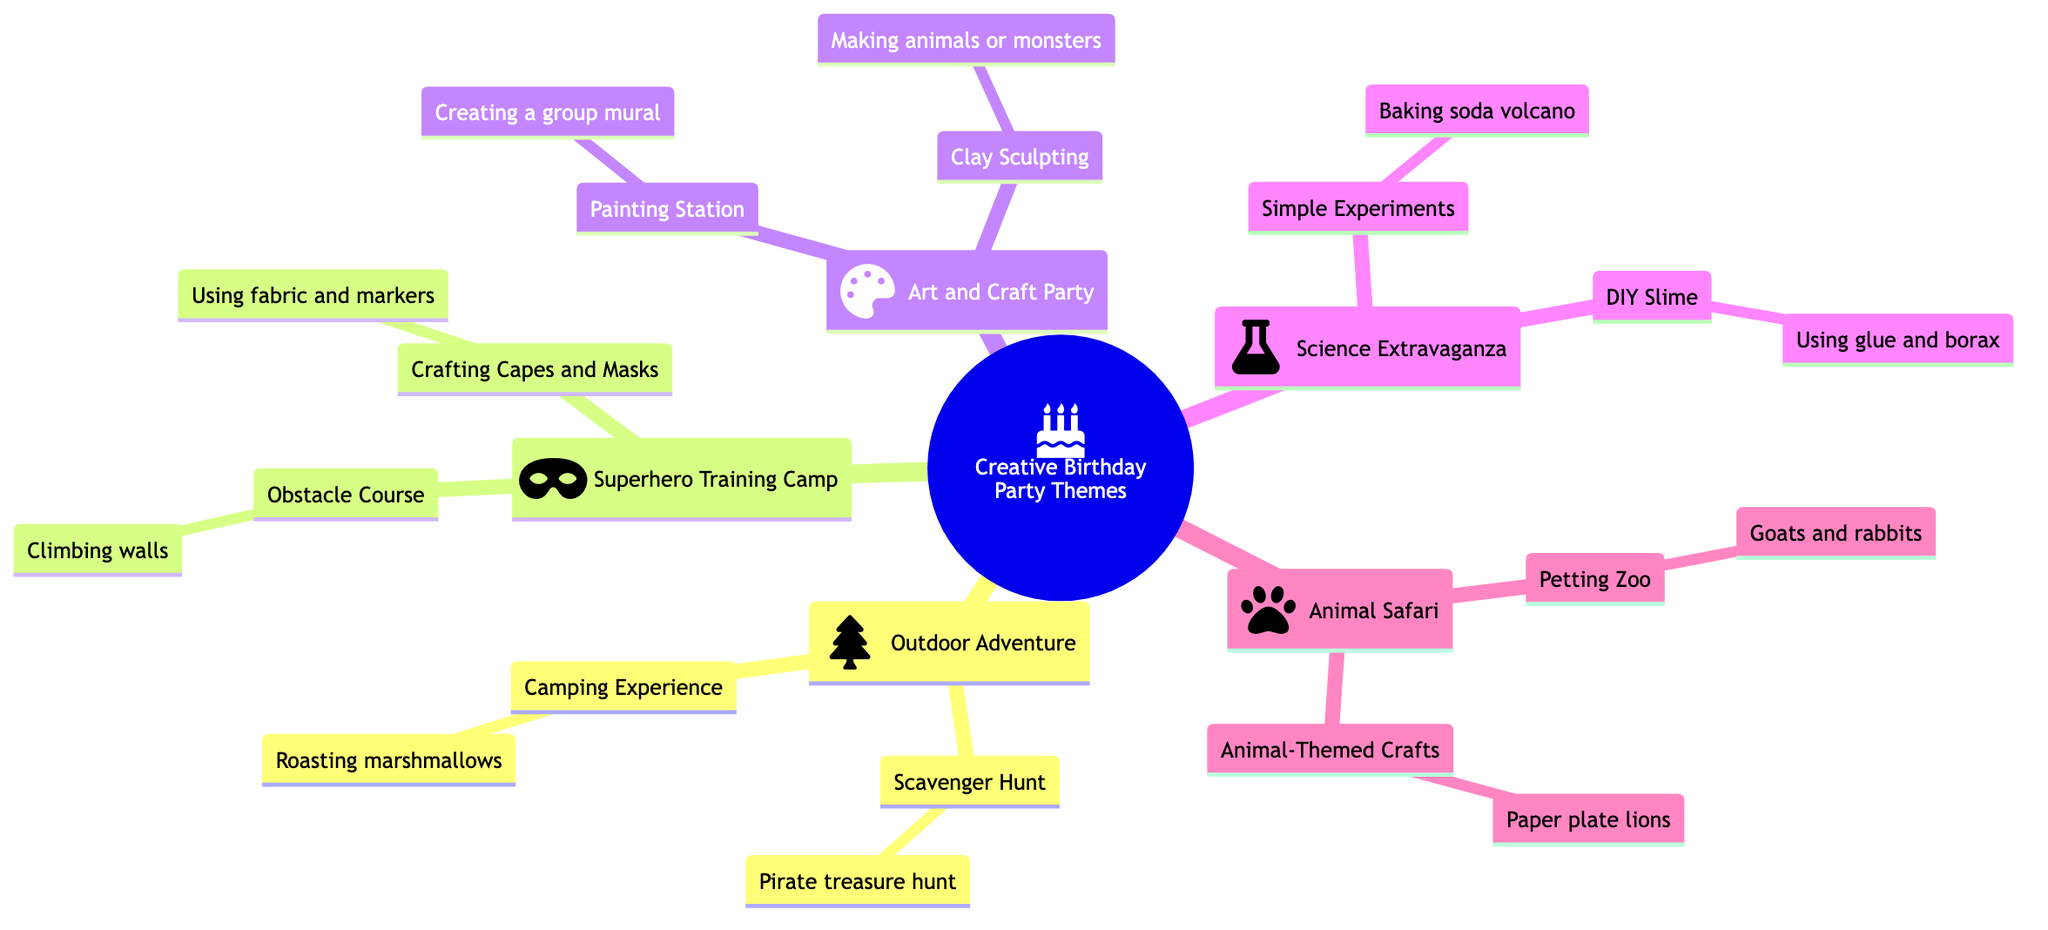What is one activity in the Outdoor Adventure theme? The Outdoor Adventure theme includes activities like Scavenger Hunt and Camping Experience. The question asks for one activity, so we can take either of those. The Scavenger Hunt involves kids following clues to find hidden treasures, while Camping Experience includes setting up tents and having a faux campfire.
Answer: Scavenger Hunt How many main themes are in the diagram? The diagram shows five main themes: Outdoor Adventure, Superhero Training Camp, Art and Craft Party, Science Extravaganza, and Animal Safari. To answer this question, I can simply count the number of themes listed under the main node "Creative Birthday Party Themes."
Answer: 5 What is an example of an activity in the Science Extravaganza theme? The Science Extravaganza theme lists two activities: Simple Experiments and DIY Slime. An example of an activity in this theme can be either of those. Among them, DIY Slime involves kids making their own slime using glue and borax.
Answer: DIY Slime Which theme includes a Petting Zoo? The Petting Zoo is listed under the Animal Safari theme. The question is directly related to identifying which of the main themes contains this specific activity, which is clearly noted in the diagram.
Answer: Animal Safari What do kids do in the Crafting Capes and Masks activity? In the Crafting Capes and Masks activity under the Superhero Training Camp theme, kids design their own superhero costumes using fabric and markers. This information can be directly retrieved by inspecting the node for Crafting Capes and Masks in the diagram.
Answer: Design superhero costumes Which activity allows kids to create a group mural? The Painting Station is where kids paint on canvases or paper, and an example noted is creating a large group mural. This can be determined by looking at the Art and Craft Party section where the Painting Station is mentioned.
Answer: Creating a group mural How many activities are under the Animal Safari theme? Under the Animal Safari theme, there are two activities listed: Petting Zoo and Animal-Themed Crafts. This question requires counting the nodes connected to the Animal Safari branch, leading to the answer.
Answer: 2 What type of experience does the Camping Experience activity provide? The Camping Experience activity is described to provide a faux camping experience where kids set up tents and have activities like roasting marshmallows. By looking at the node, the nature of the experience can be articulated based on its description.
Answer: Faux campfire What do kids make in the Clay Sculpting activity? In the Clay Sculpting activity under the Art and Craft Party, kids make sculptures out of clay, with an example being the creation of animals or monsters. This answer comes from examining the description attached to the Clay Sculpting node.
Answer: Sculptures out of clay 